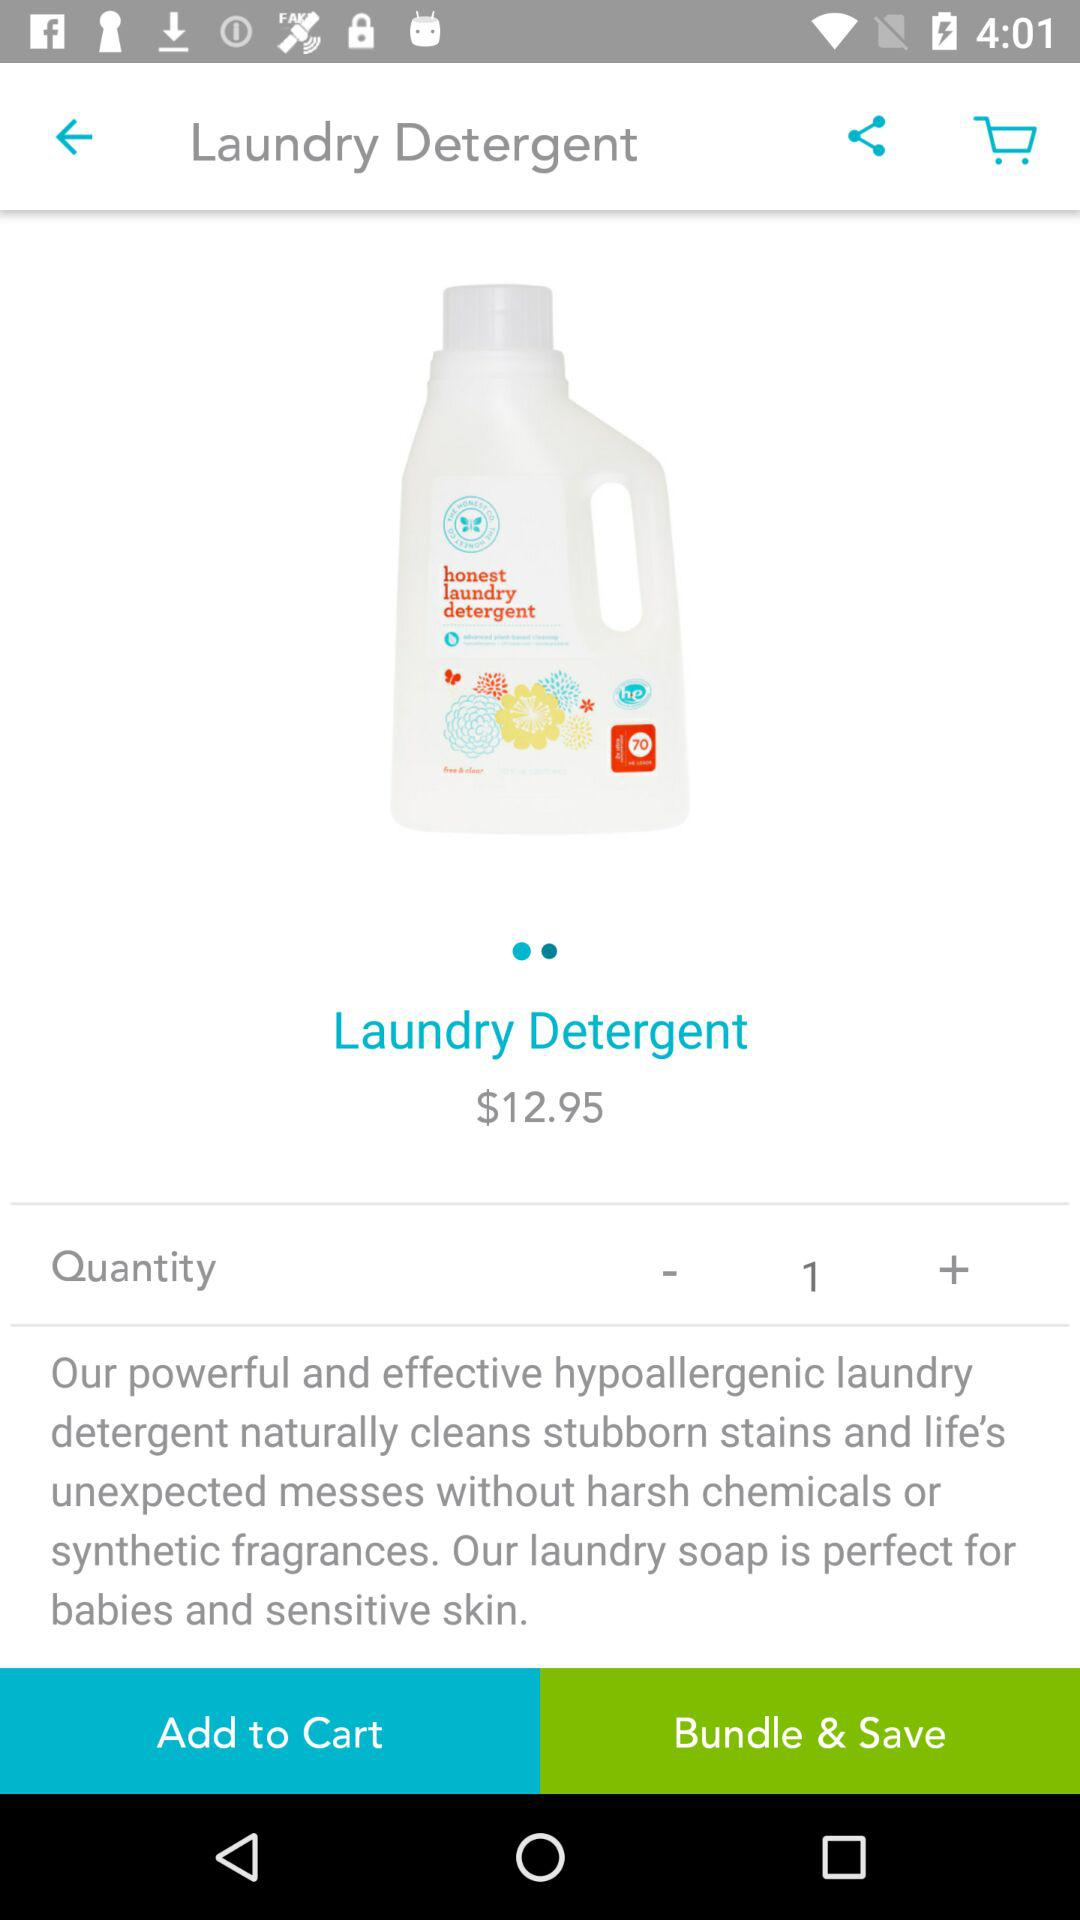What is the name of the product? The name of the product is "Laundry Detergent". 